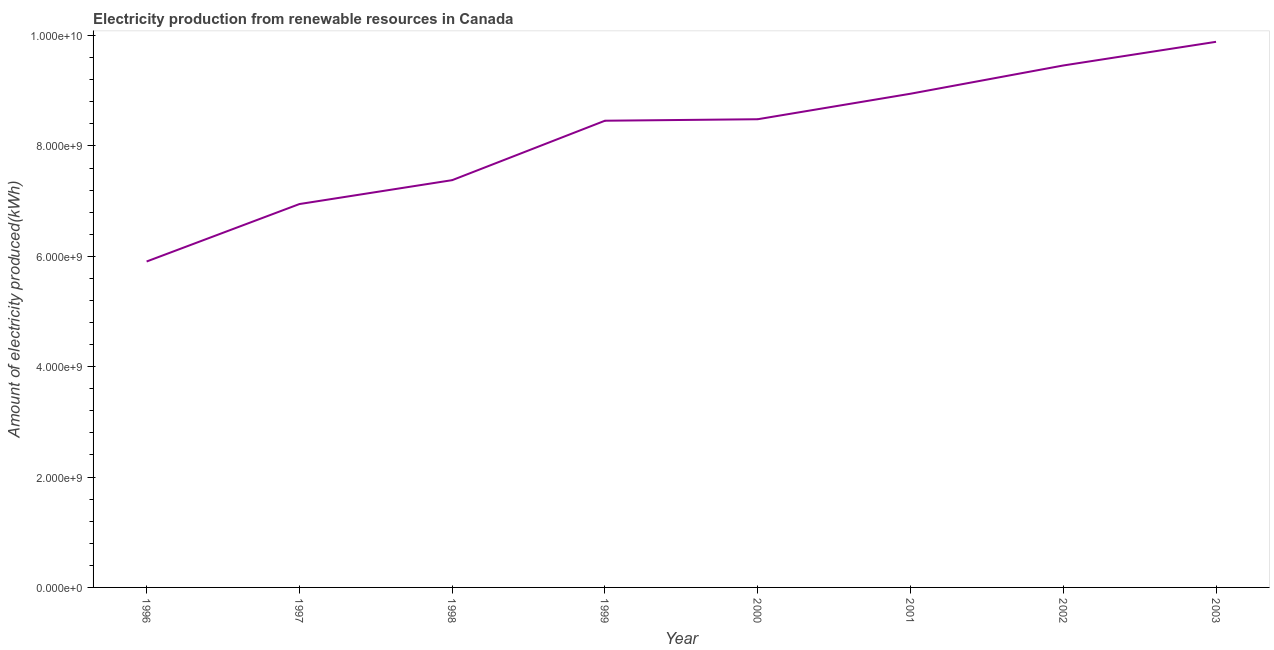What is the amount of electricity produced in 1996?
Your answer should be very brief. 5.91e+09. Across all years, what is the maximum amount of electricity produced?
Give a very brief answer. 9.89e+09. Across all years, what is the minimum amount of electricity produced?
Your response must be concise. 5.91e+09. In which year was the amount of electricity produced minimum?
Make the answer very short. 1996. What is the sum of the amount of electricity produced?
Offer a very short reply. 6.55e+1. What is the difference between the amount of electricity produced in 2002 and 2003?
Provide a short and direct response. -4.29e+08. What is the average amount of electricity produced per year?
Your answer should be very brief. 8.18e+09. What is the median amount of electricity produced?
Your answer should be very brief. 8.47e+09. In how many years, is the amount of electricity produced greater than 4800000000 kWh?
Keep it short and to the point. 8. Do a majority of the years between 1998 and 2001 (inclusive) have amount of electricity produced greater than 2800000000 kWh?
Offer a terse response. Yes. What is the ratio of the amount of electricity produced in 2001 to that in 2003?
Keep it short and to the point. 0.9. Is the amount of electricity produced in 1997 less than that in 2000?
Provide a succinct answer. Yes. What is the difference between the highest and the second highest amount of electricity produced?
Offer a very short reply. 4.29e+08. Is the sum of the amount of electricity produced in 1998 and 1999 greater than the maximum amount of electricity produced across all years?
Provide a short and direct response. Yes. What is the difference between the highest and the lowest amount of electricity produced?
Ensure brevity in your answer.  3.98e+09. In how many years, is the amount of electricity produced greater than the average amount of electricity produced taken over all years?
Provide a succinct answer. 5. How many lines are there?
Ensure brevity in your answer.  1. How many years are there in the graph?
Give a very brief answer. 8. What is the difference between two consecutive major ticks on the Y-axis?
Offer a terse response. 2.00e+09. Does the graph contain any zero values?
Keep it short and to the point. No. Does the graph contain grids?
Your answer should be very brief. No. What is the title of the graph?
Provide a succinct answer. Electricity production from renewable resources in Canada. What is the label or title of the X-axis?
Your response must be concise. Year. What is the label or title of the Y-axis?
Offer a very short reply. Amount of electricity produced(kWh). What is the Amount of electricity produced(kWh) of 1996?
Give a very brief answer. 5.91e+09. What is the Amount of electricity produced(kWh) in 1997?
Your response must be concise. 6.95e+09. What is the Amount of electricity produced(kWh) of 1998?
Provide a succinct answer. 7.38e+09. What is the Amount of electricity produced(kWh) of 1999?
Provide a short and direct response. 8.46e+09. What is the Amount of electricity produced(kWh) in 2000?
Make the answer very short. 8.48e+09. What is the Amount of electricity produced(kWh) of 2001?
Make the answer very short. 8.95e+09. What is the Amount of electricity produced(kWh) of 2002?
Make the answer very short. 9.46e+09. What is the Amount of electricity produced(kWh) of 2003?
Ensure brevity in your answer.  9.89e+09. What is the difference between the Amount of electricity produced(kWh) in 1996 and 1997?
Keep it short and to the point. -1.04e+09. What is the difference between the Amount of electricity produced(kWh) in 1996 and 1998?
Your answer should be very brief. -1.47e+09. What is the difference between the Amount of electricity produced(kWh) in 1996 and 1999?
Keep it short and to the point. -2.55e+09. What is the difference between the Amount of electricity produced(kWh) in 1996 and 2000?
Keep it short and to the point. -2.58e+09. What is the difference between the Amount of electricity produced(kWh) in 1996 and 2001?
Offer a very short reply. -3.04e+09. What is the difference between the Amount of electricity produced(kWh) in 1996 and 2002?
Your response must be concise. -3.55e+09. What is the difference between the Amount of electricity produced(kWh) in 1996 and 2003?
Provide a succinct answer. -3.98e+09. What is the difference between the Amount of electricity produced(kWh) in 1997 and 1998?
Keep it short and to the point. -4.33e+08. What is the difference between the Amount of electricity produced(kWh) in 1997 and 1999?
Your answer should be compact. -1.51e+09. What is the difference between the Amount of electricity produced(kWh) in 1997 and 2000?
Keep it short and to the point. -1.54e+09. What is the difference between the Amount of electricity produced(kWh) in 1997 and 2001?
Give a very brief answer. -2.00e+09. What is the difference between the Amount of electricity produced(kWh) in 1997 and 2002?
Keep it short and to the point. -2.51e+09. What is the difference between the Amount of electricity produced(kWh) in 1997 and 2003?
Your answer should be very brief. -2.94e+09. What is the difference between the Amount of electricity produced(kWh) in 1998 and 1999?
Ensure brevity in your answer.  -1.08e+09. What is the difference between the Amount of electricity produced(kWh) in 1998 and 2000?
Give a very brief answer. -1.10e+09. What is the difference between the Amount of electricity produced(kWh) in 1998 and 2001?
Give a very brief answer. -1.57e+09. What is the difference between the Amount of electricity produced(kWh) in 1998 and 2002?
Offer a very short reply. -2.08e+09. What is the difference between the Amount of electricity produced(kWh) in 1998 and 2003?
Make the answer very short. -2.51e+09. What is the difference between the Amount of electricity produced(kWh) in 1999 and 2000?
Keep it short and to the point. -2.70e+07. What is the difference between the Amount of electricity produced(kWh) in 1999 and 2001?
Your answer should be very brief. -4.89e+08. What is the difference between the Amount of electricity produced(kWh) in 1999 and 2002?
Make the answer very short. -1.00e+09. What is the difference between the Amount of electricity produced(kWh) in 1999 and 2003?
Your answer should be compact. -1.43e+09. What is the difference between the Amount of electricity produced(kWh) in 2000 and 2001?
Make the answer very short. -4.62e+08. What is the difference between the Amount of electricity produced(kWh) in 2000 and 2002?
Provide a short and direct response. -9.74e+08. What is the difference between the Amount of electricity produced(kWh) in 2000 and 2003?
Your answer should be very brief. -1.40e+09. What is the difference between the Amount of electricity produced(kWh) in 2001 and 2002?
Ensure brevity in your answer.  -5.12e+08. What is the difference between the Amount of electricity produced(kWh) in 2001 and 2003?
Your answer should be compact. -9.41e+08. What is the difference between the Amount of electricity produced(kWh) in 2002 and 2003?
Give a very brief answer. -4.29e+08. What is the ratio of the Amount of electricity produced(kWh) in 1996 to that in 1999?
Make the answer very short. 0.7. What is the ratio of the Amount of electricity produced(kWh) in 1996 to that in 2000?
Your answer should be very brief. 0.7. What is the ratio of the Amount of electricity produced(kWh) in 1996 to that in 2001?
Provide a succinct answer. 0.66. What is the ratio of the Amount of electricity produced(kWh) in 1996 to that in 2002?
Keep it short and to the point. 0.62. What is the ratio of the Amount of electricity produced(kWh) in 1996 to that in 2003?
Your answer should be compact. 0.6. What is the ratio of the Amount of electricity produced(kWh) in 1997 to that in 1998?
Ensure brevity in your answer.  0.94. What is the ratio of the Amount of electricity produced(kWh) in 1997 to that in 1999?
Make the answer very short. 0.82. What is the ratio of the Amount of electricity produced(kWh) in 1997 to that in 2000?
Ensure brevity in your answer.  0.82. What is the ratio of the Amount of electricity produced(kWh) in 1997 to that in 2001?
Offer a very short reply. 0.78. What is the ratio of the Amount of electricity produced(kWh) in 1997 to that in 2002?
Your answer should be very brief. 0.73. What is the ratio of the Amount of electricity produced(kWh) in 1997 to that in 2003?
Provide a succinct answer. 0.7. What is the ratio of the Amount of electricity produced(kWh) in 1998 to that in 1999?
Make the answer very short. 0.87. What is the ratio of the Amount of electricity produced(kWh) in 1998 to that in 2000?
Your response must be concise. 0.87. What is the ratio of the Amount of electricity produced(kWh) in 1998 to that in 2001?
Your answer should be very brief. 0.82. What is the ratio of the Amount of electricity produced(kWh) in 1998 to that in 2002?
Ensure brevity in your answer.  0.78. What is the ratio of the Amount of electricity produced(kWh) in 1998 to that in 2003?
Your answer should be compact. 0.75. What is the ratio of the Amount of electricity produced(kWh) in 1999 to that in 2001?
Your answer should be compact. 0.94. What is the ratio of the Amount of electricity produced(kWh) in 1999 to that in 2002?
Your answer should be very brief. 0.89. What is the ratio of the Amount of electricity produced(kWh) in 1999 to that in 2003?
Give a very brief answer. 0.85. What is the ratio of the Amount of electricity produced(kWh) in 2000 to that in 2001?
Provide a short and direct response. 0.95. What is the ratio of the Amount of electricity produced(kWh) in 2000 to that in 2002?
Give a very brief answer. 0.9. What is the ratio of the Amount of electricity produced(kWh) in 2000 to that in 2003?
Offer a terse response. 0.86. What is the ratio of the Amount of electricity produced(kWh) in 2001 to that in 2002?
Keep it short and to the point. 0.95. What is the ratio of the Amount of electricity produced(kWh) in 2001 to that in 2003?
Give a very brief answer. 0.91. 